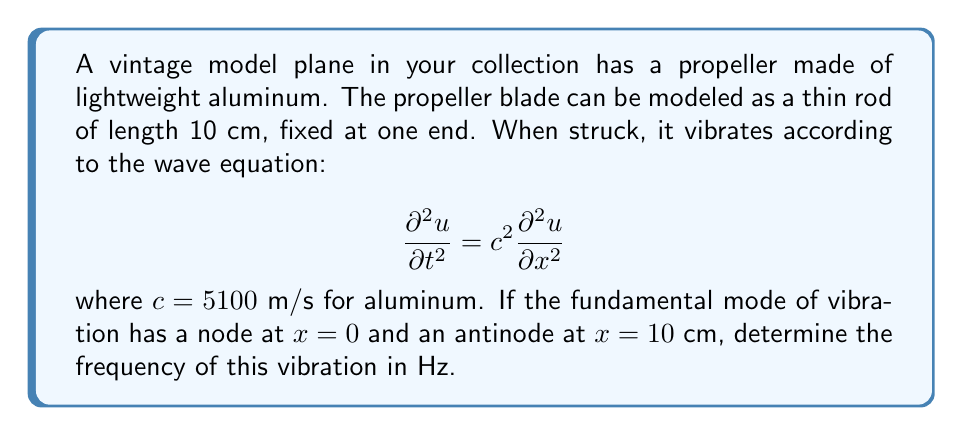Solve this math problem. To solve this problem, we'll follow these steps:

1) For a rod fixed at one end, the fundamental mode of vibration has a wavelength four times the length of the rod. So:
   $$\lambda = 4L = 4 \cdot 0.10 \text{ m} = 0.40 \text{ m}$$

2) The wave number $k$ is related to the wavelength by:
   $$k = \frac{2\pi}{\lambda} = \frac{2\pi}{0.40} = 15.71 \text{ m}^{-1}$$

3) For a wave equation, the angular frequency $\omega$ is related to the wave number $k$ and wave speed $c$ by:
   $$\omega = ck$$

4) Substituting the values:
   $$\omega = 5100 \text{ m/s} \cdot 15.71 \text{ m}^{-1} = 80,121 \text{ rad/s}$$

5) The frequency $f$ is related to the angular frequency by:
   $$f = \frac{\omega}{2\pi} = \frac{80,121}{2\pi} = 12,750 \text{ Hz}$$

Thus, the frequency of the fundamental mode of vibration is approximately 12,750 Hz.
Answer: 12,750 Hz 